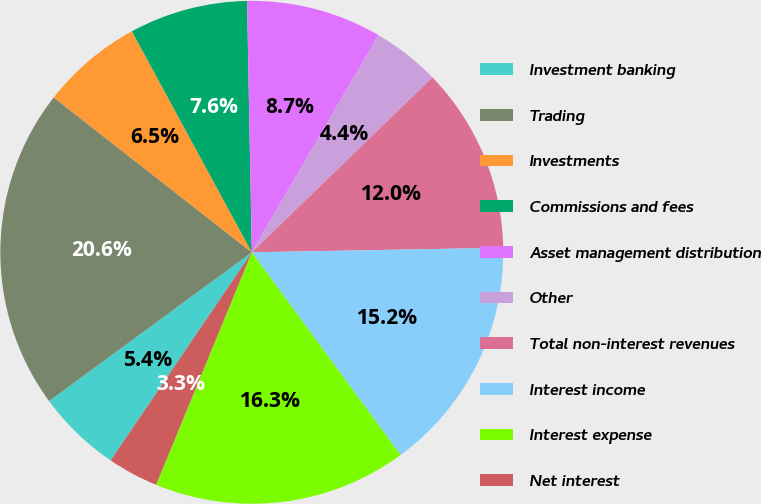Convert chart to OTSL. <chart><loc_0><loc_0><loc_500><loc_500><pie_chart><fcel>Investment banking<fcel>Trading<fcel>Investments<fcel>Commissions and fees<fcel>Asset management distribution<fcel>Other<fcel>Total non-interest revenues<fcel>Interest income<fcel>Interest expense<fcel>Net interest<nl><fcel>5.44%<fcel>20.63%<fcel>6.53%<fcel>7.61%<fcel>8.7%<fcel>4.36%<fcel>11.95%<fcel>15.21%<fcel>16.29%<fcel>3.27%<nl></chart> 